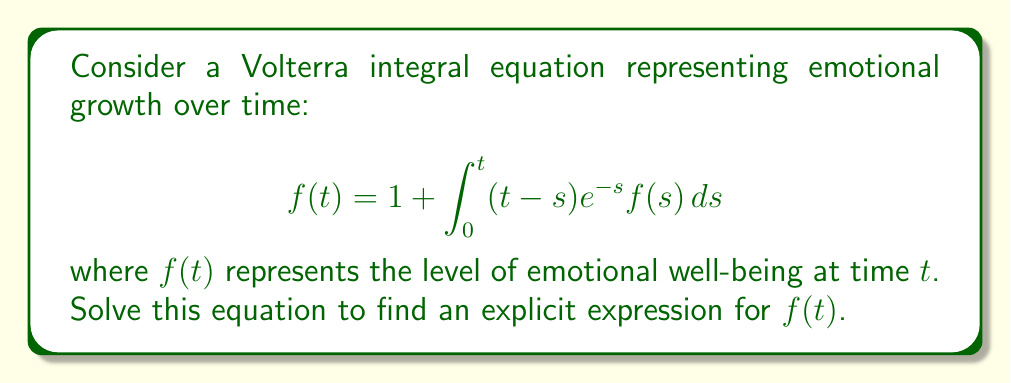Solve this math problem. To solve this Volterra integral equation, we'll use the Laplace transform method:

1) Take the Laplace transform of both sides:
   $$\mathcal{L}\{f(t)\} = \mathcal{L}\{1\} + \mathcal{L}\{\int_0^t (t-s)e^{-s}f(s)ds\}$$

2) Using Laplace transform properties:
   $$F(p) = \frac{1}{p} + \mathcal{L}\{(t-s)e^{-s}\} \cdot F(p)$$

3) Calculate $\mathcal{L}\{(t-s)e^{-s}\}$:
   $$\mathcal{L}\{(t-s)e^{-s}\} = \mathcal{L}\{te^{-s}\} - \mathcal{L}\{se^{-s}\} = \frac{1}{(p+1)^2}$$

4) Substitute back:
   $$F(p) = \frac{1}{p} + \frac{1}{(p+1)^2}F(p)$$

5) Solve for $F(p)$:
   $$F(p) = \frac{1}{p} + \frac{F(p)}{(p+1)^2}$$
   $$F(p)(1 - \frac{1}{(p+1)^2}) = \frac{1}{p}$$
   $$F(p) = \frac{(p+1)^2}{p((p+1)^2-1)} = \frac{(p+1)^2}{p(p^2+2p)}$$

6) Decompose into partial fractions:
   $$F(p) = \frac{1}{p} + \frac{2}{p+2}$$

7) Take the inverse Laplace transform:
   $$f(t) = \mathcal{L}^{-1}\{\frac{1}{p} + \frac{2}{p+2}\} = 1 + 2e^{-2t}$$

This solution represents emotional growth starting at 3 (when $t=0$) and asymptotically approaching 1 as time progresses, modeling a therapeutic process where initial heightened emotions gradually stabilize.
Answer: $f(t) = 1 + 2e^{-2t}$ 